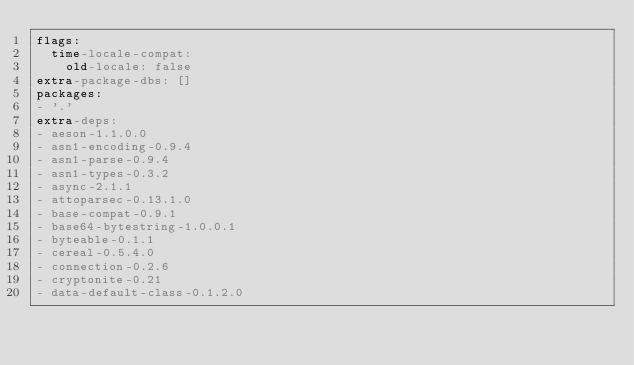Convert code to text. <code><loc_0><loc_0><loc_500><loc_500><_YAML_>flags:
  time-locale-compat:
    old-locale: false
extra-package-dbs: []
packages:
- '.'
extra-deps:
- aeson-1.1.0.0
- asn1-encoding-0.9.4
- asn1-parse-0.9.4
- asn1-types-0.3.2
- async-2.1.1
- attoparsec-0.13.1.0
- base-compat-0.9.1
- base64-bytestring-1.0.0.1
- byteable-0.1.1
- cereal-0.5.4.0
- connection-0.2.6
- cryptonite-0.21
- data-default-class-0.1.2.0</code> 